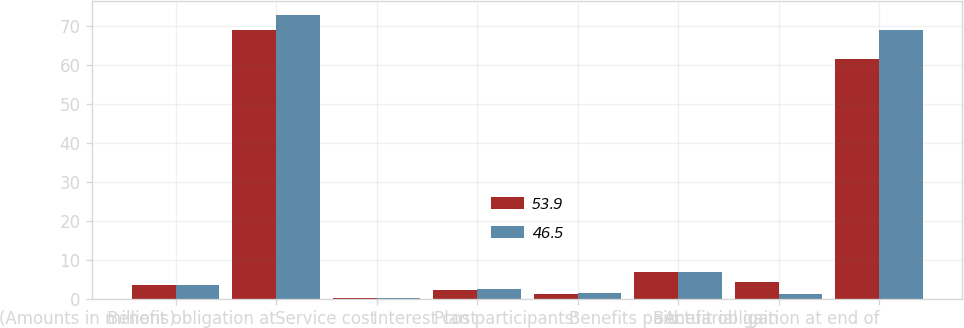<chart> <loc_0><loc_0><loc_500><loc_500><stacked_bar_chart><ecel><fcel>(Amounts in millions)<fcel>Benefit obligation at<fcel>Service cost<fcel>Interest cost<fcel>Plan participants'<fcel>Benefits paid<fcel>Actuarial gain<fcel>Benefit obligation at end of<nl><fcel>53.9<fcel>3.4<fcel>69<fcel>0.1<fcel>2.2<fcel>1.2<fcel>6.8<fcel>4.2<fcel>61.5<nl><fcel>46.5<fcel>3.4<fcel>72.8<fcel>0.2<fcel>2.6<fcel>1.4<fcel>6.8<fcel>1.2<fcel>69<nl></chart> 